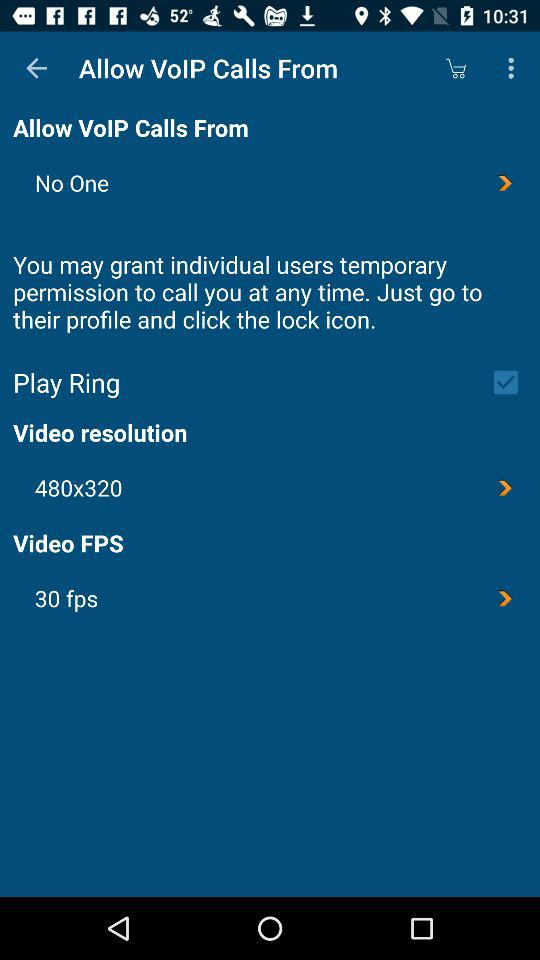What is selected in "Allow VoIP Calls From"? The selected option is "No One". 